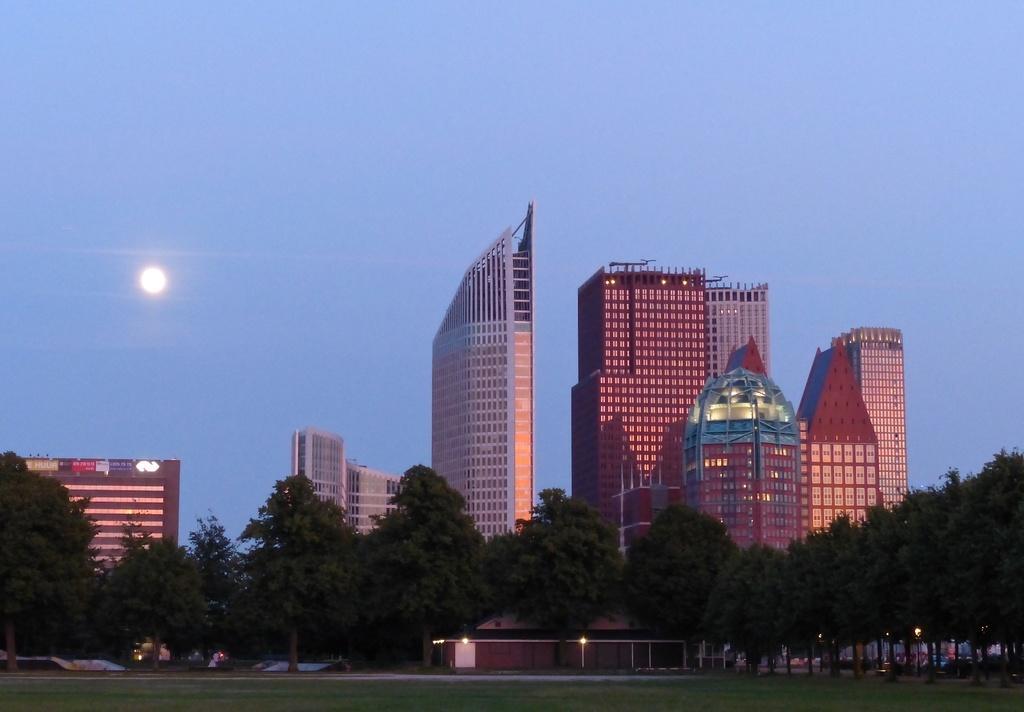How would you summarize this image in a sentence or two? This picture shows buildings and trees and we see few lights and we see moon in the blue sky and grass on the ground 